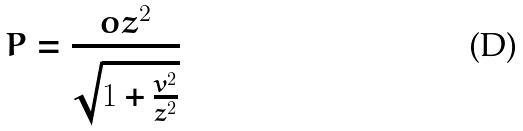<formula> <loc_0><loc_0><loc_500><loc_500>P = \frac { o z ^ { 2 } } { \sqrt { 1 + \frac { v ^ { 2 } } { z ^ { 2 } } } }</formula> 